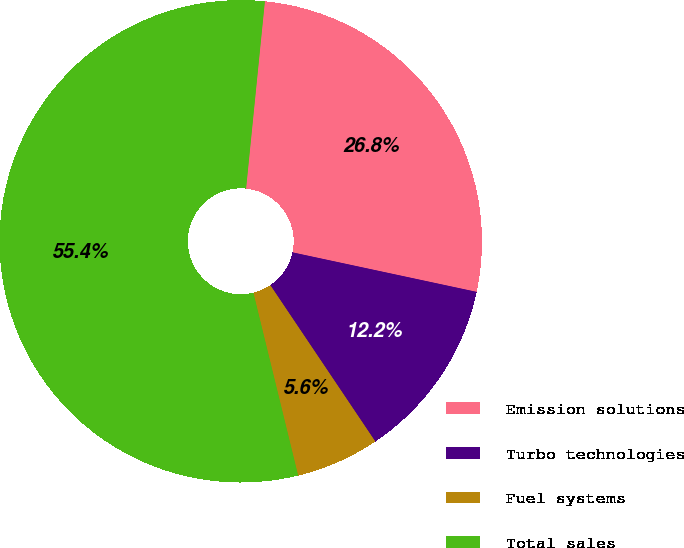<chart> <loc_0><loc_0><loc_500><loc_500><pie_chart><fcel>Emission solutions<fcel>Turbo technologies<fcel>Fuel systems<fcel>Total sales<nl><fcel>26.77%<fcel>12.22%<fcel>5.59%<fcel>55.41%<nl></chart> 